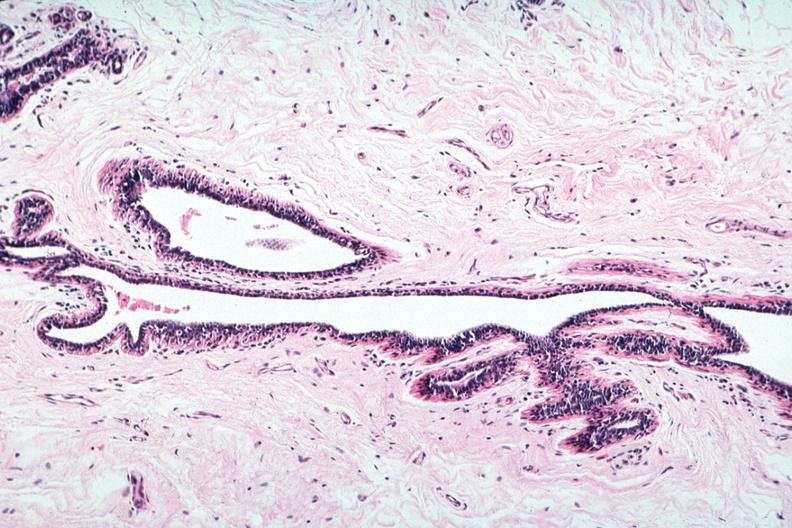s cachexia present?
Answer the question using a single word or phrase. No 